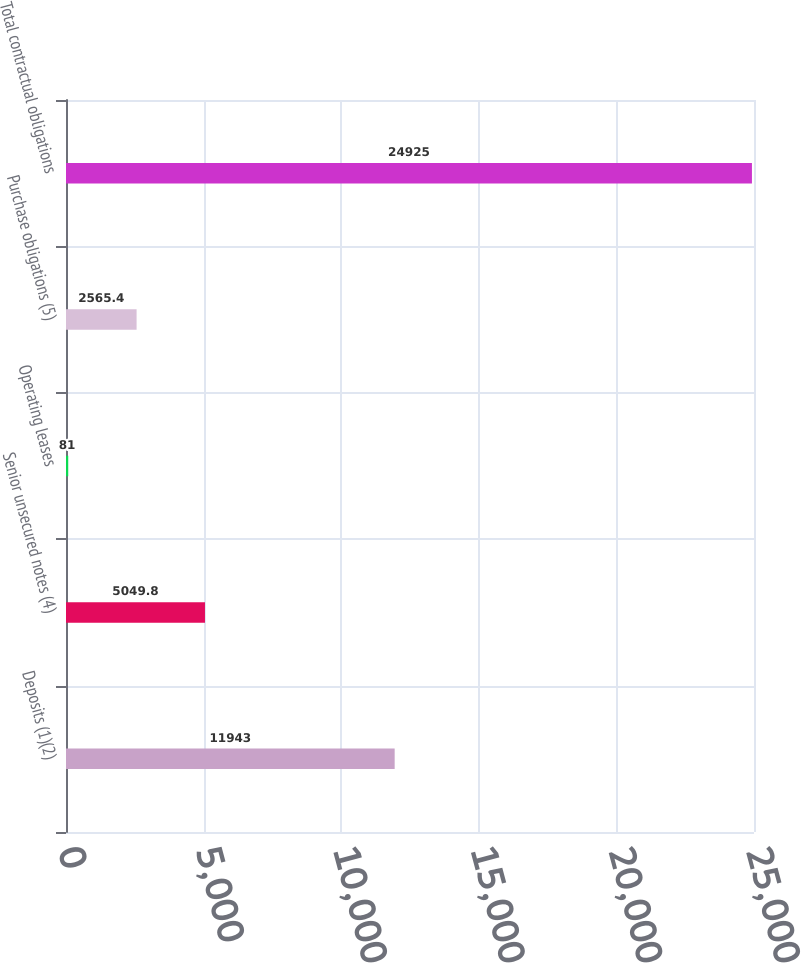Convert chart to OTSL. <chart><loc_0><loc_0><loc_500><loc_500><bar_chart><fcel>Deposits (1)(2)<fcel>Senior unsecured notes (4)<fcel>Operating leases<fcel>Purchase obligations (5)<fcel>Total contractual obligations<nl><fcel>11943<fcel>5049.8<fcel>81<fcel>2565.4<fcel>24925<nl></chart> 